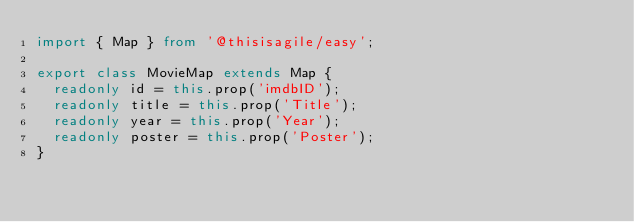<code> <loc_0><loc_0><loc_500><loc_500><_TypeScript_>import { Map } from '@thisisagile/easy';

export class MovieMap extends Map {
  readonly id = this.prop('imdbID');
  readonly title = this.prop('Title');
  readonly year = this.prop('Year');
  readonly poster = this.prop('Poster');
}
</code> 